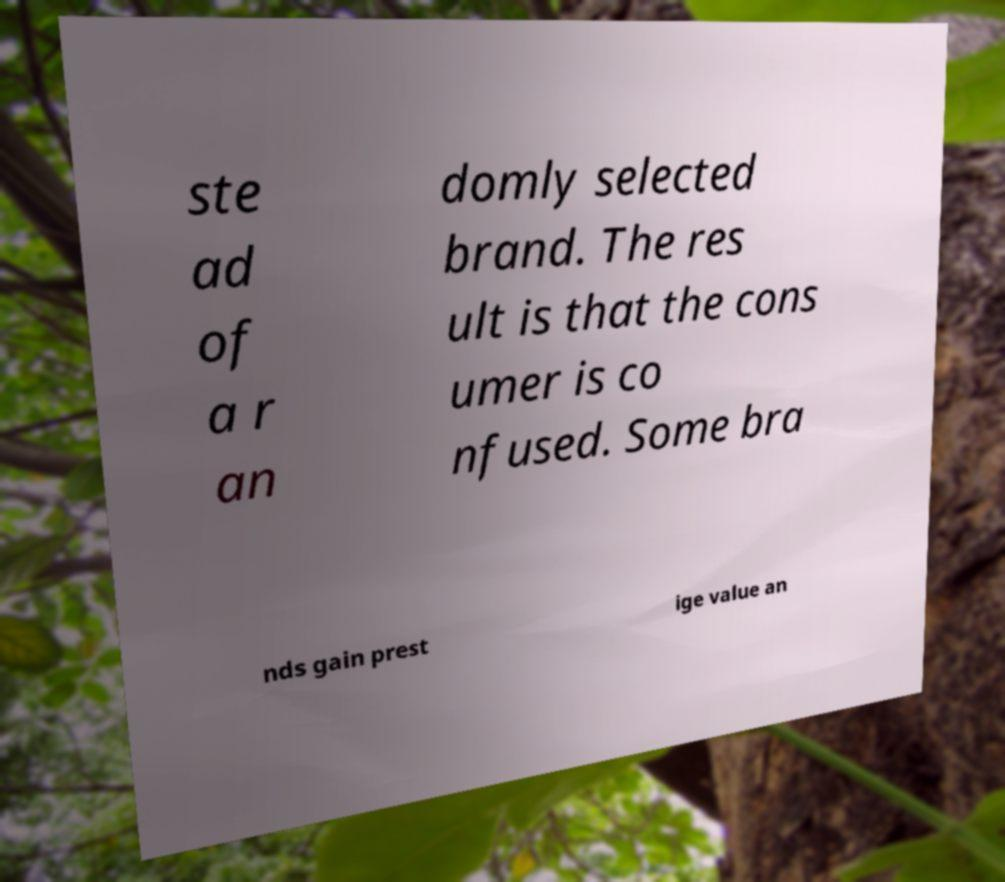Can you read and provide the text displayed in the image?This photo seems to have some interesting text. Can you extract and type it out for me? ste ad of a r an domly selected brand. The res ult is that the cons umer is co nfused. Some bra nds gain prest ige value an 